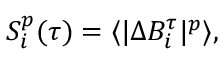Convert formula to latex. <formula><loc_0><loc_0><loc_500><loc_500>\begin{array} { r } { S _ { i } ^ { p } ( \tau ) = \langle | \Delta B _ { i } ^ { \tau } | ^ { p } \rangle , } \end{array}</formula> 